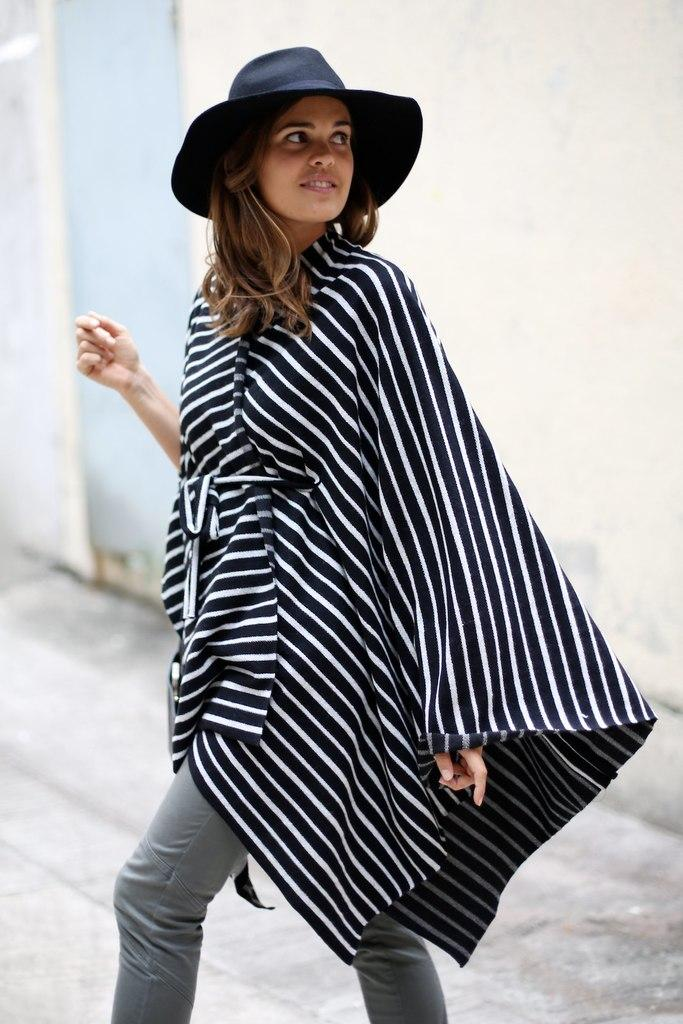Who is the main subject in the image? There is a woman in the image. What is the woman wearing? The woman is wearing a black and white striped dress and a black hat. What is the woman doing in the image? The woman is walking in the street. What can be seen in the background of the image? There is a wall in the background of the image. What type of bell can be heard ringing in the image? There is no bell present in the image, and therefore no sound can be heard. 